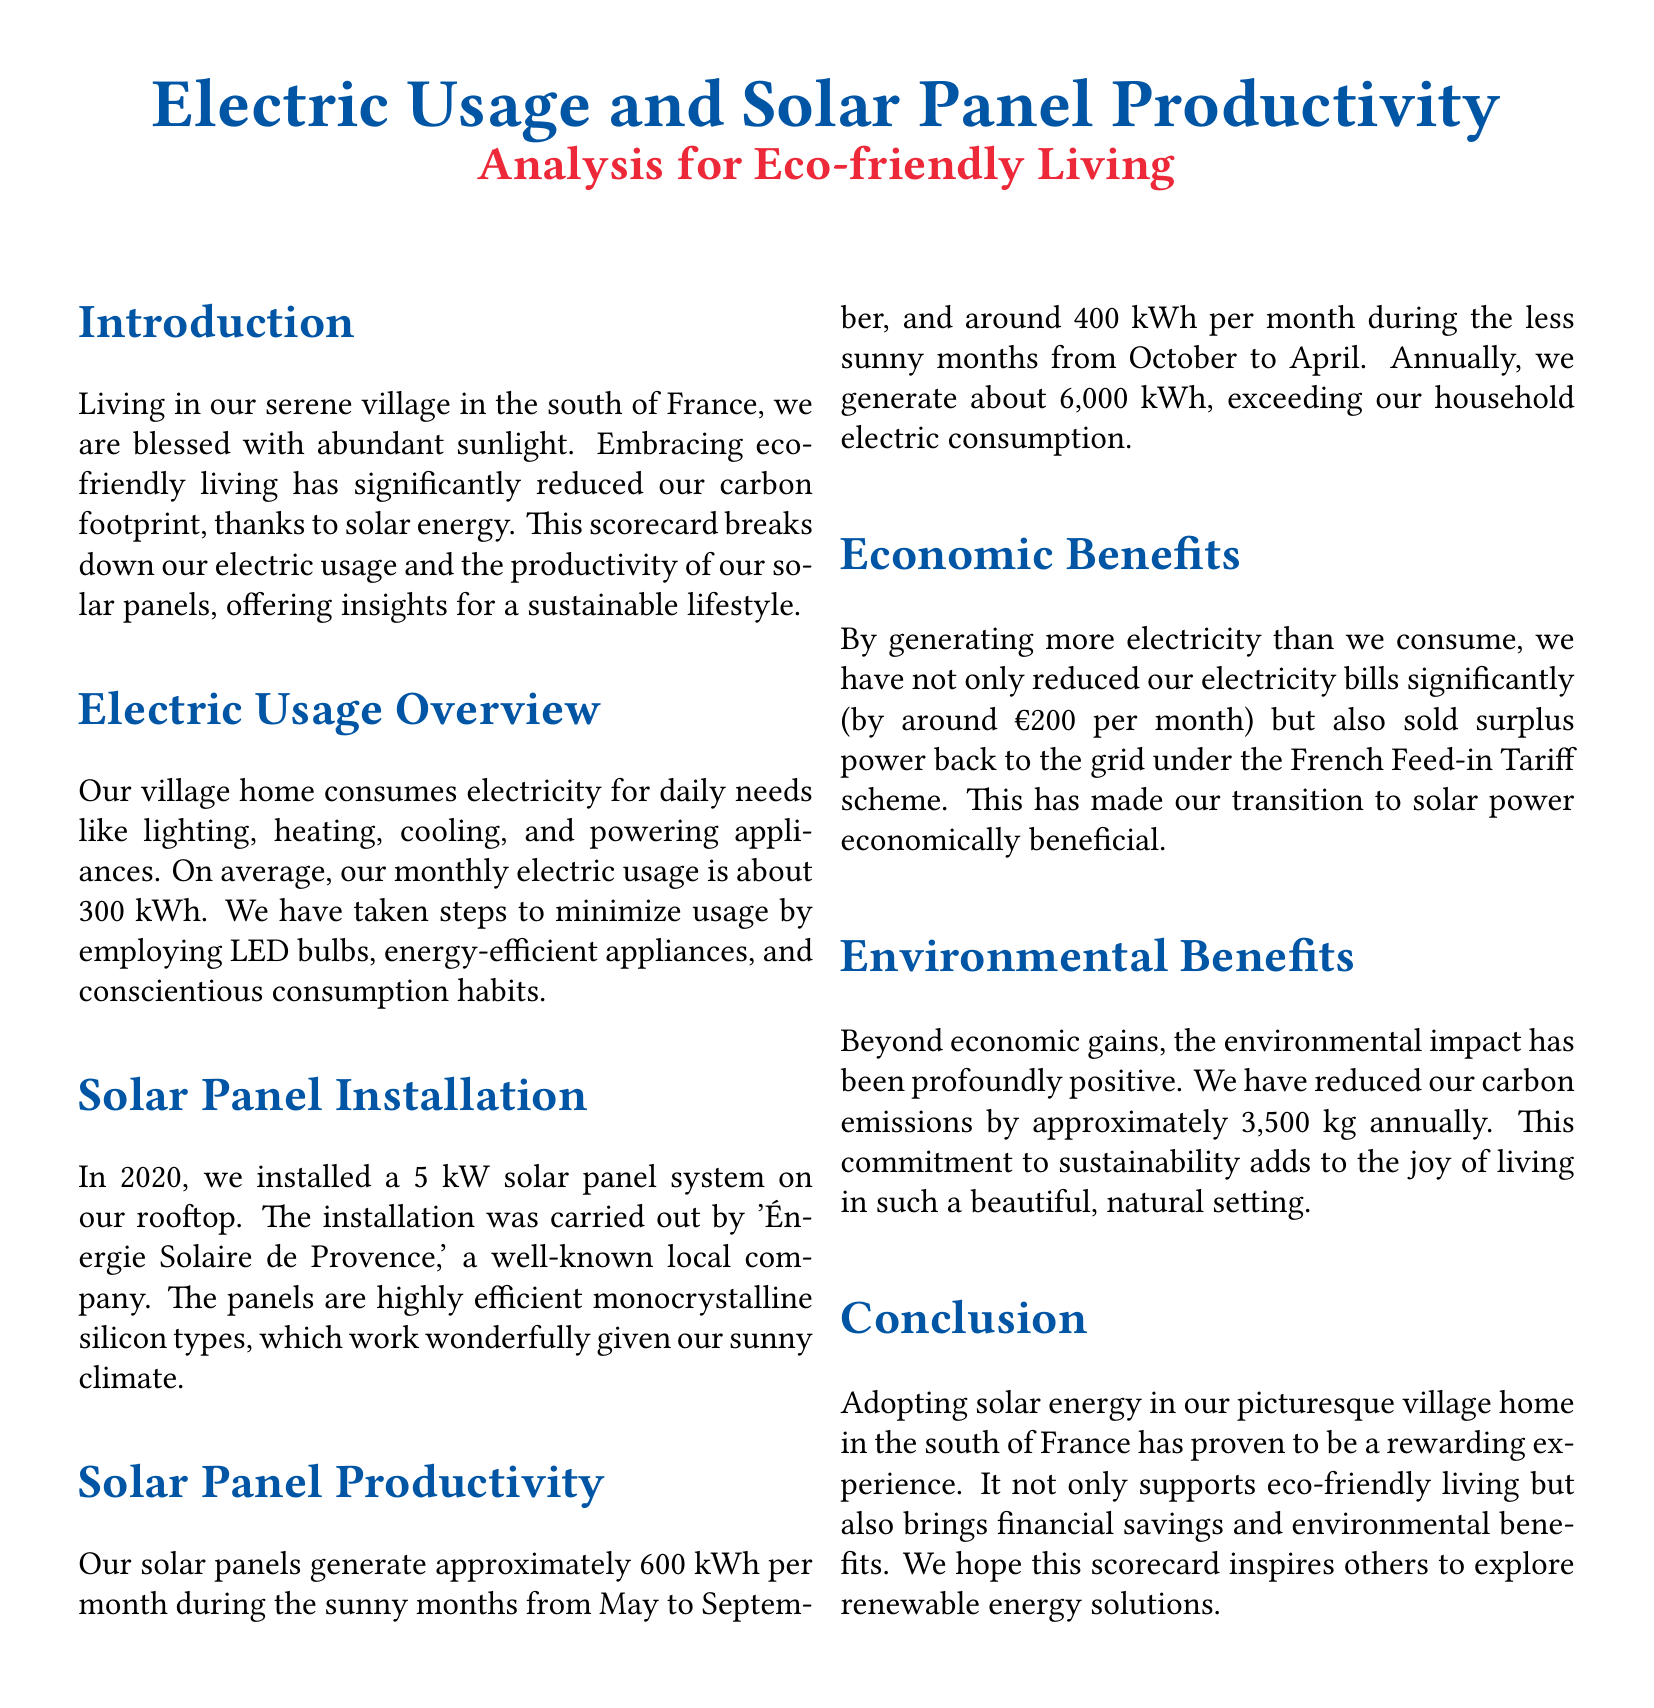What is the average monthly electric usage? The average monthly electric usage mentioned is about 300 kWh.
Answer: 300 kWh What year was the solar panel system installed? The solar panel system was installed in the year 2020.
Answer: 2020 How much electricity do the solar panels generate annually? The document states that the solar panels generate about 6,000 kWh annually.
Answer: 6,000 kWh What is the monthly savings on electricity bills? The monthly savings on electricity bills is around €200.
Answer: €200 How much have carbon emissions been reduced annually? The document mentions that carbon emissions have been reduced by approximately 3,500 kg annually.
Answer: 3,500 kg Which company installed the solar panels? The solar panels were installed by 'Énergie Solaire de Provence.'
Answer: Énergie Solaire de Provence In which months do the solar panels generate around 600 kWh? The solar panels generate approximately 600 kWh during the sunny months from May to September.
Answer: May to September What type of solar panels were installed? The type of solar panels installed are highly efficient monocrystalline silicon types.
Answer: monocrystalline silicon What is the ecological benefit of adopting solar energy? The ecological benefit includes the significant reduction in carbon emissions.
Answer: reduction in carbon emissions 